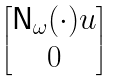Convert formula to latex. <formula><loc_0><loc_0><loc_500><loc_500>\begin{bmatrix} { \mathsf N } _ { \omega } ( \cdot ) u \\ 0 \end{bmatrix}</formula> 